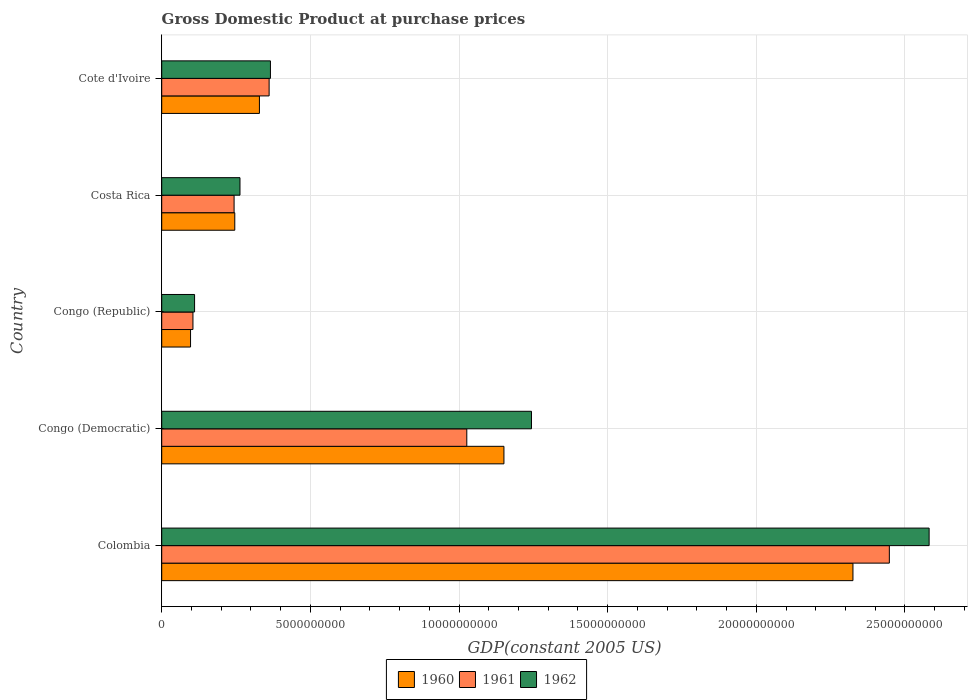How many different coloured bars are there?
Ensure brevity in your answer.  3. What is the label of the 1st group of bars from the top?
Give a very brief answer. Cote d'Ivoire. What is the GDP at purchase prices in 1962 in Congo (Democratic)?
Your response must be concise. 1.24e+1. Across all countries, what is the maximum GDP at purchase prices in 1960?
Your answer should be very brief. 2.32e+1. Across all countries, what is the minimum GDP at purchase prices in 1962?
Provide a succinct answer. 1.11e+09. In which country was the GDP at purchase prices in 1961 minimum?
Make the answer very short. Congo (Republic). What is the total GDP at purchase prices in 1962 in the graph?
Give a very brief answer. 4.56e+1. What is the difference between the GDP at purchase prices in 1961 in Costa Rica and that in Cote d'Ivoire?
Offer a terse response. -1.18e+09. What is the difference between the GDP at purchase prices in 1961 in Congo (Republic) and the GDP at purchase prices in 1960 in Cote d'Ivoire?
Keep it short and to the point. -2.24e+09. What is the average GDP at purchase prices in 1960 per country?
Keep it short and to the point. 8.29e+09. What is the difference between the GDP at purchase prices in 1962 and GDP at purchase prices in 1961 in Congo (Republic)?
Provide a short and direct response. 5.47e+07. In how many countries, is the GDP at purchase prices in 1960 greater than 22000000000 US$?
Make the answer very short. 1. What is the ratio of the GDP at purchase prices in 1960 in Costa Rica to that in Cote d'Ivoire?
Give a very brief answer. 0.75. Is the GDP at purchase prices in 1960 in Congo (Republic) less than that in Costa Rica?
Your answer should be very brief. Yes. Is the difference between the GDP at purchase prices in 1962 in Congo (Republic) and Costa Rica greater than the difference between the GDP at purchase prices in 1961 in Congo (Republic) and Costa Rica?
Provide a short and direct response. No. What is the difference between the highest and the second highest GDP at purchase prices in 1961?
Ensure brevity in your answer.  1.42e+1. What is the difference between the highest and the lowest GDP at purchase prices in 1961?
Your answer should be compact. 2.34e+1. What does the 2nd bar from the bottom in Congo (Republic) represents?
Offer a terse response. 1961. How many bars are there?
Give a very brief answer. 15. Are all the bars in the graph horizontal?
Give a very brief answer. Yes. How many legend labels are there?
Your answer should be compact. 3. What is the title of the graph?
Your answer should be compact. Gross Domestic Product at purchase prices. Does "1989" appear as one of the legend labels in the graph?
Offer a terse response. No. What is the label or title of the X-axis?
Give a very brief answer. GDP(constant 2005 US). What is the GDP(constant 2005 US) of 1960 in Colombia?
Your response must be concise. 2.32e+1. What is the GDP(constant 2005 US) in 1961 in Colombia?
Your response must be concise. 2.45e+1. What is the GDP(constant 2005 US) of 1962 in Colombia?
Your answer should be very brief. 2.58e+1. What is the GDP(constant 2005 US) of 1960 in Congo (Democratic)?
Make the answer very short. 1.15e+1. What is the GDP(constant 2005 US) in 1961 in Congo (Democratic)?
Your answer should be compact. 1.03e+1. What is the GDP(constant 2005 US) in 1962 in Congo (Democratic)?
Your answer should be very brief. 1.24e+1. What is the GDP(constant 2005 US) of 1960 in Congo (Republic)?
Offer a terse response. 9.70e+08. What is the GDP(constant 2005 US) in 1961 in Congo (Republic)?
Your answer should be compact. 1.05e+09. What is the GDP(constant 2005 US) of 1962 in Congo (Republic)?
Offer a terse response. 1.11e+09. What is the GDP(constant 2005 US) in 1960 in Costa Rica?
Offer a terse response. 2.46e+09. What is the GDP(constant 2005 US) in 1961 in Costa Rica?
Your answer should be compact. 2.43e+09. What is the GDP(constant 2005 US) of 1962 in Costa Rica?
Offer a very short reply. 2.63e+09. What is the GDP(constant 2005 US) of 1960 in Cote d'Ivoire?
Keep it short and to the point. 3.29e+09. What is the GDP(constant 2005 US) of 1961 in Cote d'Ivoire?
Your answer should be compact. 3.61e+09. What is the GDP(constant 2005 US) of 1962 in Cote d'Ivoire?
Your answer should be compact. 3.66e+09. Across all countries, what is the maximum GDP(constant 2005 US) of 1960?
Keep it short and to the point. 2.32e+1. Across all countries, what is the maximum GDP(constant 2005 US) in 1961?
Provide a short and direct response. 2.45e+1. Across all countries, what is the maximum GDP(constant 2005 US) of 1962?
Offer a very short reply. 2.58e+1. Across all countries, what is the minimum GDP(constant 2005 US) in 1960?
Your response must be concise. 9.70e+08. Across all countries, what is the minimum GDP(constant 2005 US) of 1961?
Keep it short and to the point. 1.05e+09. Across all countries, what is the minimum GDP(constant 2005 US) of 1962?
Offer a terse response. 1.11e+09. What is the total GDP(constant 2005 US) in 1960 in the graph?
Ensure brevity in your answer.  4.15e+1. What is the total GDP(constant 2005 US) in 1961 in the graph?
Give a very brief answer. 4.18e+1. What is the total GDP(constant 2005 US) in 1962 in the graph?
Keep it short and to the point. 4.56e+1. What is the difference between the GDP(constant 2005 US) of 1960 in Colombia and that in Congo (Democratic)?
Your answer should be very brief. 1.17e+1. What is the difference between the GDP(constant 2005 US) of 1961 in Colombia and that in Congo (Democratic)?
Your answer should be compact. 1.42e+1. What is the difference between the GDP(constant 2005 US) of 1962 in Colombia and that in Congo (Democratic)?
Provide a succinct answer. 1.34e+1. What is the difference between the GDP(constant 2005 US) of 1960 in Colombia and that in Congo (Republic)?
Your response must be concise. 2.23e+1. What is the difference between the GDP(constant 2005 US) of 1961 in Colombia and that in Congo (Republic)?
Provide a short and direct response. 2.34e+1. What is the difference between the GDP(constant 2005 US) in 1962 in Colombia and that in Congo (Republic)?
Give a very brief answer. 2.47e+1. What is the difference between the GDP(constant 2005 US) of 1960 in Colombia and that in Costa Rica?
Your response must be concise. 2.08e+1. What is the difference between the GDP(constant 2005 US) in 1961 in Colombia and that in Costa Rica?
Your answer should be very brief. 2.20e+1. What is the difference between the GDP(constant 2005 US) in 1962 in Colombia and that in Costa Rica?
Provide a short and direct response. 2.32e+1. What is the difference between the GDP(constant 2005 US) of 1960 in Colombia and that in Cote d'Ivoire?
Offer a very short reply. 2.00e+1. What is the difference between the GDP(constant 2005 US) in 1961 in Colombia and that in Cote d'Ivoire?
Offer a very short reply. 2.09e+1. What is the difference between the GDP(constant 2005 US) of 1962 in Colombia and that in Cote d'Ivoire?
Offer a very short reply. 2.22e+1. What is the difference between the GDP(constant 2005 US) of 1960 in Congo (Democratic) and that in Congo (Republic)?
Keep it short and to the point. 1.05e+1. What is the difference between the GDP(constant 2005 US) in 1961 in Congo (Democratic) and that in Congo (Republic)?
Make the answer very short. 9.21e+09. What is the difference between the GDP(constant 2005 US) of 1962 in Congo (Democratic) and that in Congo (Republic)?
Offer a very short reply. 1.13e+1. What is the difference between the GDP(constant 2005 US) of 1960 in Congo (Democratic) and that in Costa Rica?
Make the answer very short. 9.05e+09. What is the difference between the GDP(constant 2005 US) in 1961 in Congo (Democratic) and that in Costa Rica?
Keep it short and to the point. 7.83e+09. What is the difference between the GDP(constant 2005 US) of 1962 in Congo (Democratic) and that in Costa Rica?
Offer a very short reply. 9.80e+09. What is the difference between the GDP(constant 2005 US) of 1960 in Congo (Democratic) and that in Cote d'Ivoire?
Offer a very short reply. 8.22e+09. What is the difference between the GDP(constant 2005 US) in 1961 in Congo (Democratic) and that in Cote d'Ivoire?
Ensure brevity in your answer.  6.65e+09. What is the difference between the GDP(constant 2005 US) in 1962 in Congo (Democratic) and that in Cote d'Ivoire?
Offer a terse response. 8.78e+09. What is the difference between the GDP(constant 2005 US) in 1960 in Congo (Republic) and that in Costa Rica?
Keep it short and to the point. -1.49e+09. What is the difference between the GDP(constant 2005 US) of 1961 in Congo (Republic) and that in Costa Rica?
Offer a terse response. -1.38e+09. What is the difference between the GDP(constant 2005 US) of 1962 in Congo (Republic) and that in Costa Rica?
Your answer should be compact. -1.53e+09. What is the difference between the GDP(constant 2005 US) in 1960 in Congo (Republic) and that in Cote d'Ivoire?
Provide a succinct answer. -2.32e+09. What is the difference between the GDP(constant 2005 US) of 1961 in Congo (Republic) and that in Cote d'Ivoire?
Provide a succinct answer. -2.56e+09. What is the difference between the GDP(constant 2005 US) in 1962 in Congo (Republic) and that in Cote d'Ivoire?
Ensure brevity in your answer.  -2.55e+09. What is the difference between the GDP(constant 2005 US) of 1960 in Costa Rica and that in Cote d'Ivoire?
Make the answer very short. -8.28e+08. What is the difference between the GDP(constant 2005 US) in 1961 in Costa Rica and that in Cote d'Ivoire?
Provide a succinct answer. -1.18e+09. What is the difference between the GDP(constant 2005 US) in 1962 in Costa Rica and that in Cote d'Ivoire?
Offer a terse response. -1.02e+09. What is the difference between the GDP(constant 2005 US) of 1960 in Colombia and the GDP(constant 2005 US) of 1961 in Congo (Democratic)?
Keep it short and to the point. 1.30e+1. What is the difference between the GDP(constant 2005 US) in 1960 in Colombia and the GDP(constant 2005 US) in 1962 in Congo (Democratic)?
Offer a very short reply. 1.08e+1. What is the difference between the GDP(constant 2005 US) of 1961 in Colombia and the GDP(constant 2005 US) of 1962 in Congo (Democratic)?
Your response must be concise. 1.20e+1. What is the difference between the GDP(constant 2005 US) of 1960 in Colombia and the GDP(constant 2005 US) of 1961 in Congo (Republic)?
Provide a succinct answer. 2.22e+1. What is the difference between the GDP(constant 2005 US) of 1960 in Colombia and the GDP(constant 2005 US) of 1962 in Congo (Republic)?
Your answer should be compact. 2.21e+1. What is the difference between the GDP(constant 2005 US) in 1961 in Colombia and the GDP(constant 2005 US) in 1962 in Congo (Republic)?
Keep it short and to the point. 2.34e+1. What is the difference between the GDP(constant 2005 US) in 1960 in Colombia and the GDP(constant 2005 US) in 1961 in Costa Rica?
Offer a terse response. 2.08e+1. What is the difference between the GDP(constant 2005 US) in 1960 in Colombia and the GDP(constant 2005 US) in 1962 in Costa Rica?
Make the answer very short. 2.06e+1. What is the difference between the GDP(constant 2005 US) in 1961 in Colombia and the GDP(constant 2005 US) in 1962 in Costa Rica?
Make the answer very short. 2.18e+1. What is the difference between the GDP(constant 2005 US) in 1960 in Colombia and the GDP(constant 2005 US) in 1961 in Cote d'Ivoire?
Provide a succinct answer. 1.96e+1. What is the difference between the GDP(constant 2005 US) of 1960 in Colombia and the GDP(constant 2005 US) of 1962 in Cote d'Ivoire?
Offer a terse response. 1.96e+1. What is the difference between the GDP(constant 2005 US) in 1961 in Colombia and the GDP(constant 2005 US) in 1962 in Cote d'Ivoire?
Your answer should be very brief. 2.08e+1. What is the difference between the GDP(constant 2005 US) of 1960 in Congo (Democratic) and the GDP(constant 2005 US) of 1961 in Congo (Republic)?
Keep it short and to the point. 1.05e+1. What is the difference between the GDP(constant 2005 US) of 1960 in Congo (Democratic) and the GDP(constant 2005 US) of 1962 in Congo (Republic)?
Offer a very short reply. 1.04e+1. What is the difference between the GDP(constant 2005 US) in 1961 in Congo (Democratic) and the GDP(constant 2005 US) in 1962 in Congo (Republic)?
Offer a very short reply. 9.16e+09. What is the difference between the GDP(constant 2005 US) in 1960 in Congo (Democratic) and the GDP(constant 2005 US) in 1961 in Costa Rica?
Your answer should be compact. 9.08e+09. What is the difference between the GDP(constant 2005 US) of 1960 in Congo (Democratic) and the GDP(constant 2005 US) of 1962 in Costa Rica?
Provide a succinct answer. 8.88e+09. What is the difference between the GDP(constant 2005 US) in 1961 in Congo (Democratic) and the GDP(constant 2005 US) in 1962 in Costa Rica?
Your response must be concise. 7.63e+09. What is the difference between the GDP(constant 2005 US) in 1960 in Congo (Democratic) and the GDP(constant 2005 US) in 1961 in Cote d'Ivoire?
Provide a short and direct response. 7.90e+09. What is the difference between the GDP(constant 2005 US) in 1960 in Congo (Democratic) and the GDP(constant 2005 US) in 1962 in Cote d'Ivoire?
Make the answer very short. 7.85e+09. What is the difference between the GDP(constant 2005 US) in 1961 in Congo (Democratic) and the GDP(constant 2005 US) in 1962 in Cote d'Ivoire?
Your answer should be compact. 6.60e+09. What is the difference between the GDP(constant 2005 US) in 1960 in Congo (Republic) and the GDP(constant 2005 US) in 1961 in Costa Rica?
Offer a terse response. -1.46e+09. What is the difference between the GDP(constant 2005 US) of 1960 in Congo (Republic) and the GDP(constant 2005 US) of 1962 in Costa Rica?
Your answer should be compact. -1.66e+09. What is the difference between the GDP(constant 2005 US) in 1961 in Congo (Republic) and the GDP(constant 2005 US) in 1962 in Costa Rica?
Make the answer very short. -1.58e+09. What is the difference between the GDP(constant 2005 US) in 1960 in Congo (Republic) and the GDP(constant 2005 US) in 1961 in Cote d'Ivoire?
Your response must be concise. -2.64e+09. What is the difference between the GDP(constant 2005 US) of 1960 in Congo (Republic) and the GDP(constant 2005 US) of 1962 in Cote d'Ivoire?
Provide a short and direct response. -2.69e+09. What is the difference between the GDP(constant 2005 US) of 1961 in Congo (Republic) and the GDP(constant 2005 US) of 1962 in Cote d'Ivoire?
Offer a very short reply. -2.61e+09. What is the difference between the GDP(constant 2005 US) in 1960 in Costa Rica and the GDP(constant 2005 US) in 1961 in Cote d'Ivoire?
Offer a terse response. -1.15e+09. What is the difference between the GDP(constant 2005 US) in 1960 in Costa Rica and the GDP(constant 2005 US) in 1962 in Cote d'Ivoire?
Provide a succinct answer. -1.20e+09. What is the difference between the GDP(constant 2005 US) of 1961 in Costa Rica and the GDP(constant 2005 US) of 1962 in Cote d'Ivoire?
Your answer should be compact. -1.22e+09. What is the average GDP(constant 2005 US) of 1960 per country?
Provide a short and direct response. 8.29e+09. What is the average GDP(constant 2005 US) of 1961 per country?
Offer a very short reply. 8.37e+09. What is the average GDP(constant 2005 US) in 1962 per country?
Your response must be concise. 9.13e+09. What is the difference between the GDP(constant 2005 US) in 1960 and GDP(constant 2005 US) in 1961 in Colombia?
Give a very brief answer. -1.22e+09. What is the difference between the GDP(constant 2005 US) in 1960 and GDP(constant 2005 US) in 1962 in Colombia?
Your answer should be compact. -2.56e+09. What is the difference between the GDP(constant 2005 US) in 1961 and GDP(constant 2005 US) in 1962 in Colombia?
Offer a terse response. -1.34e+09. What is the difference between the GDP(constant 2005 US) in 1960 and GDP(constant 2005 US) in 1961 in Congo (Democratic)?
Make the answer very short. 1.25e+09. What is the difference between the GDP(constant 2005 US) of 1960 and GDP(constant 2005 US) of 1962 in Congo (Democratic)?
Your answer should be very brief. -9.26e+08. What is the difference between the GDP(constant 2005 US) in 1961 and GDP(constant 2005 US) in 1962 in Congo (Democratic)?
Give a very brief answer. -2.18e+09. What is the difference between the GDP(constant 2005 US) of 1960 and GDP(constant 2005 US) of 1961 in Congo (Republic)?
Ensure brevity in your answer.  -8.10e+07. What is the difference between the GDP(constant 2005 US) of 1960 and GDP(constant 2005 US) of 1962 in Congo (Republic)?
Provide a short and direct response. -1.36e+08. What is the difference between the GDP(constant 2005 US) in 1961 and GDP(constant 2005 US) in 1962 in Congo (Republic)?
Make the answer very short. -5.47e+07. What is the difference between the GDP(constant 2005 US) in 1960 and GDP(constant 2005 US) in 1961 in Costa Rica?
Your answer should be compact. 2.35e+07. What is the difference between the GDP(constant 2005 US) of 1960 and GDP(constant 2005 US) of 1962 in Costa Rica?
Provide a short and direct response. -1.75e+08. What is the difference between the GDP(constant 2005 US) of 1961 and GDP(constant 2005 US) of 1962 in Costa Rica?
Provide a short and direct response. -1.98e+08. What is the difference between the GDP(constant 2005 US) of 1960 and GDP(constant 2005 US) of 1961 in Cote d'Ivoire?
Provide a short and direct response. -3.26e+08. What is the difference between the GDP(constant 2005 US) in 1960 and GDP(constant 2005 US) in 1962 in Cote d'Ivoire?
Provide a short and direct response. -3.71e+08. What is the difference between the GDP(constant 2005 US) of 1961 and GDP(constant 2005 US) of 1962 in Cote d'Ivoire?
Give a very brief answer. -4.43e+07. What is the ratio of the GDP(constant 2005 US) of 1960 in Colombia to that in Congo (Democratic)?
Provide a succinct answer. 2.02. What is the ratio of the GDP(constant 2005 US) in 1961 in Colombia to that in Congo (Democratic)?
Your answer should be compact. 2.38. What is the ratio of the GDP(constant 2005 US) of 1962 in Colombia to that in Congo (Democratic)?
Ensure brevity in your answer.  2.08. What is the ratio of the GDP(constant 2005 US) in 1960 in Colombia to that in Congo (Republic)?
Offer a terse response. 23.97. What is the ratio of the GDP(constant 2005 US) in 1961 in Colombia to that in Congo (Republic)?
Give a very brief answer. 23.29. What is the ratio of the GDP(constant 2005 US) in 1962 in Colombia to that in Congo (Republic)?
Provide a short and direct response. 23.35. What is the ratio of the GDP(constant 2005 US) in 1960 in Colombia to that in Costa Rica?
Give a very brief answer. 9.46. What is the ratio of the GDP(constant 2005 US) of 1961 in Colombia to that in Costa Rica?
Provide a succinct answer. 10.05. What is the ratio of the GDP(constant 2005 US) in 1962 in Colombia to that in Costa Rica?
Keep it short and to the point. 9.8. What is the ratio of the GDP(constant 2005 US) in 1960 in Colombia to that in Cote d'Ivoire?
Your answer should be very brief. 7.07. What is the ratio of the GDP(constant 2005 US) in 1961 in Colombia to that in Cote d'Ivoire?
Provide a short and direct response. 6.77. What is the ratio of the GDP(constant 2005 US) in 1962 in Colombia to that in Cote d'Ivoire?
Your response must be concise. 7.06. What is the ratio of the GDP(constant 2005 US) in 1960 in Congo (Democratic) to that in Congo (Republic)?
Provide a short and direct response. 11.87. What is the ratio of the GDP(constant 2005 US) in 1961 in Congo (Democratic) to that in Congo (Republic)?
Provide a short and direct response. 9.76. What is the ratio of the GDP(constant 2005 US) in 1962 in Congo (Democratic) to that in Congo (Republic)?
Your answer should be compact. 11.25. What is the ratio of the GDP(constant 2005 US) of 1960 in Congo (Democratic) to that in Costa Rica?
Provide a short and direct response. 4.68. What is the ratio of the GDP(constant 2005 US) in 1961 in Congo (Democratic) to that in Costa Rica?
Keep it short and to the point. 4.22. What is the ratio of the GDP(constant 2005 US) of 1962 in Congo (Democratic) to that in Costa Rica?
Offer a very short reply. 4.72. What is the ratio of the GDP(constant 2005 US) in 1960 in Congo (Democratic) to that in Cote d'Ivoire?
Keep it short and to the point. 3.5. What is the ratio of the GDP(constant 2005 US) of 1961 in Congo (Democratic) to that in Cote d'Ivoire?
Give a very brief answer. 2.84. What is the ratio of the GDP(constant 2005 US) in 1962 in Congo (Democratic) to that in Cote d'Ivoire?
Make the answer very short. 3.4. What is the ratio of the GDP(constant 2005 US) of 1960 in Congo (Republic) to that in Costa Rica?
Keep it short and to the point. 0.39. What is the ratio of the GDP(constant 2005 US) of 1961 in Congo (Republic) to that in Costa Rica?
Ensure brevity in your answer.  0.43. What is the ratio of the GDP(constant 2005 US) in 1962 in Congo (Republic) to that in Costa Rica?
Provide a short and direct response. 0.42. What is the ratio of the GDP(constant 2005 US) of 1960 in Congo (Republic) to that in Cote d'Ivoire?
Keep it short and to the point. 0.3. What is the ratio of the GDP(constant 2005 US) in 1961 in Congo (Republic) to that in Cote d'Ivoire?
Your response must be concise. 0.29. What is the ratio of the GDP(constant 2005 US) in 1962 in Congo (Republic) to that in Cote d'Ivoire?
Your response must be concise. 0.3. What is the ratio of the GDP(constant 2005 US) of 1960 in Costa Rica to that in Cote d'Ivoire?
Offer a terse response. 0.75. What is the ratio of the GDP(constant 2005 US) in 1961 in Costa Rica to that in Cote d'Ivoire?
Give a very brief answer. 0.67. What is the ratio of the GDP(constant 2005 US) in 1962 in Costa Rica to that in Cote d'Ivoire?
Provide a short and direct response. 0.72. What is the difference between the highest and the second highest GDP(constant 2005 US) in 1960?
Ensure brevity in your answer.  1.17e+1. What is the difference between the highest and the second highest GDP(constant 2005 US) of 1961?
Your response must be concise. 1.42e+1. What is the difference between the highest and the second highest GDP(constant 2005 US) in 1962?
Offer a terse response. 1.34e+1. What is the difference between the highest and the lowest GDP(constant 2005 US) of 1960?
Your answer should be very brief. 2.23e+1. What is the difference between the highest and the lowest GDP(constant 2005 US) of 1961?
Keep it short and to the point. 2.34e+1. What is the difference between the highest and the lowest GDP(constant 2005 US) in 1962?
Give a very brief answer. 2.47e+1. 